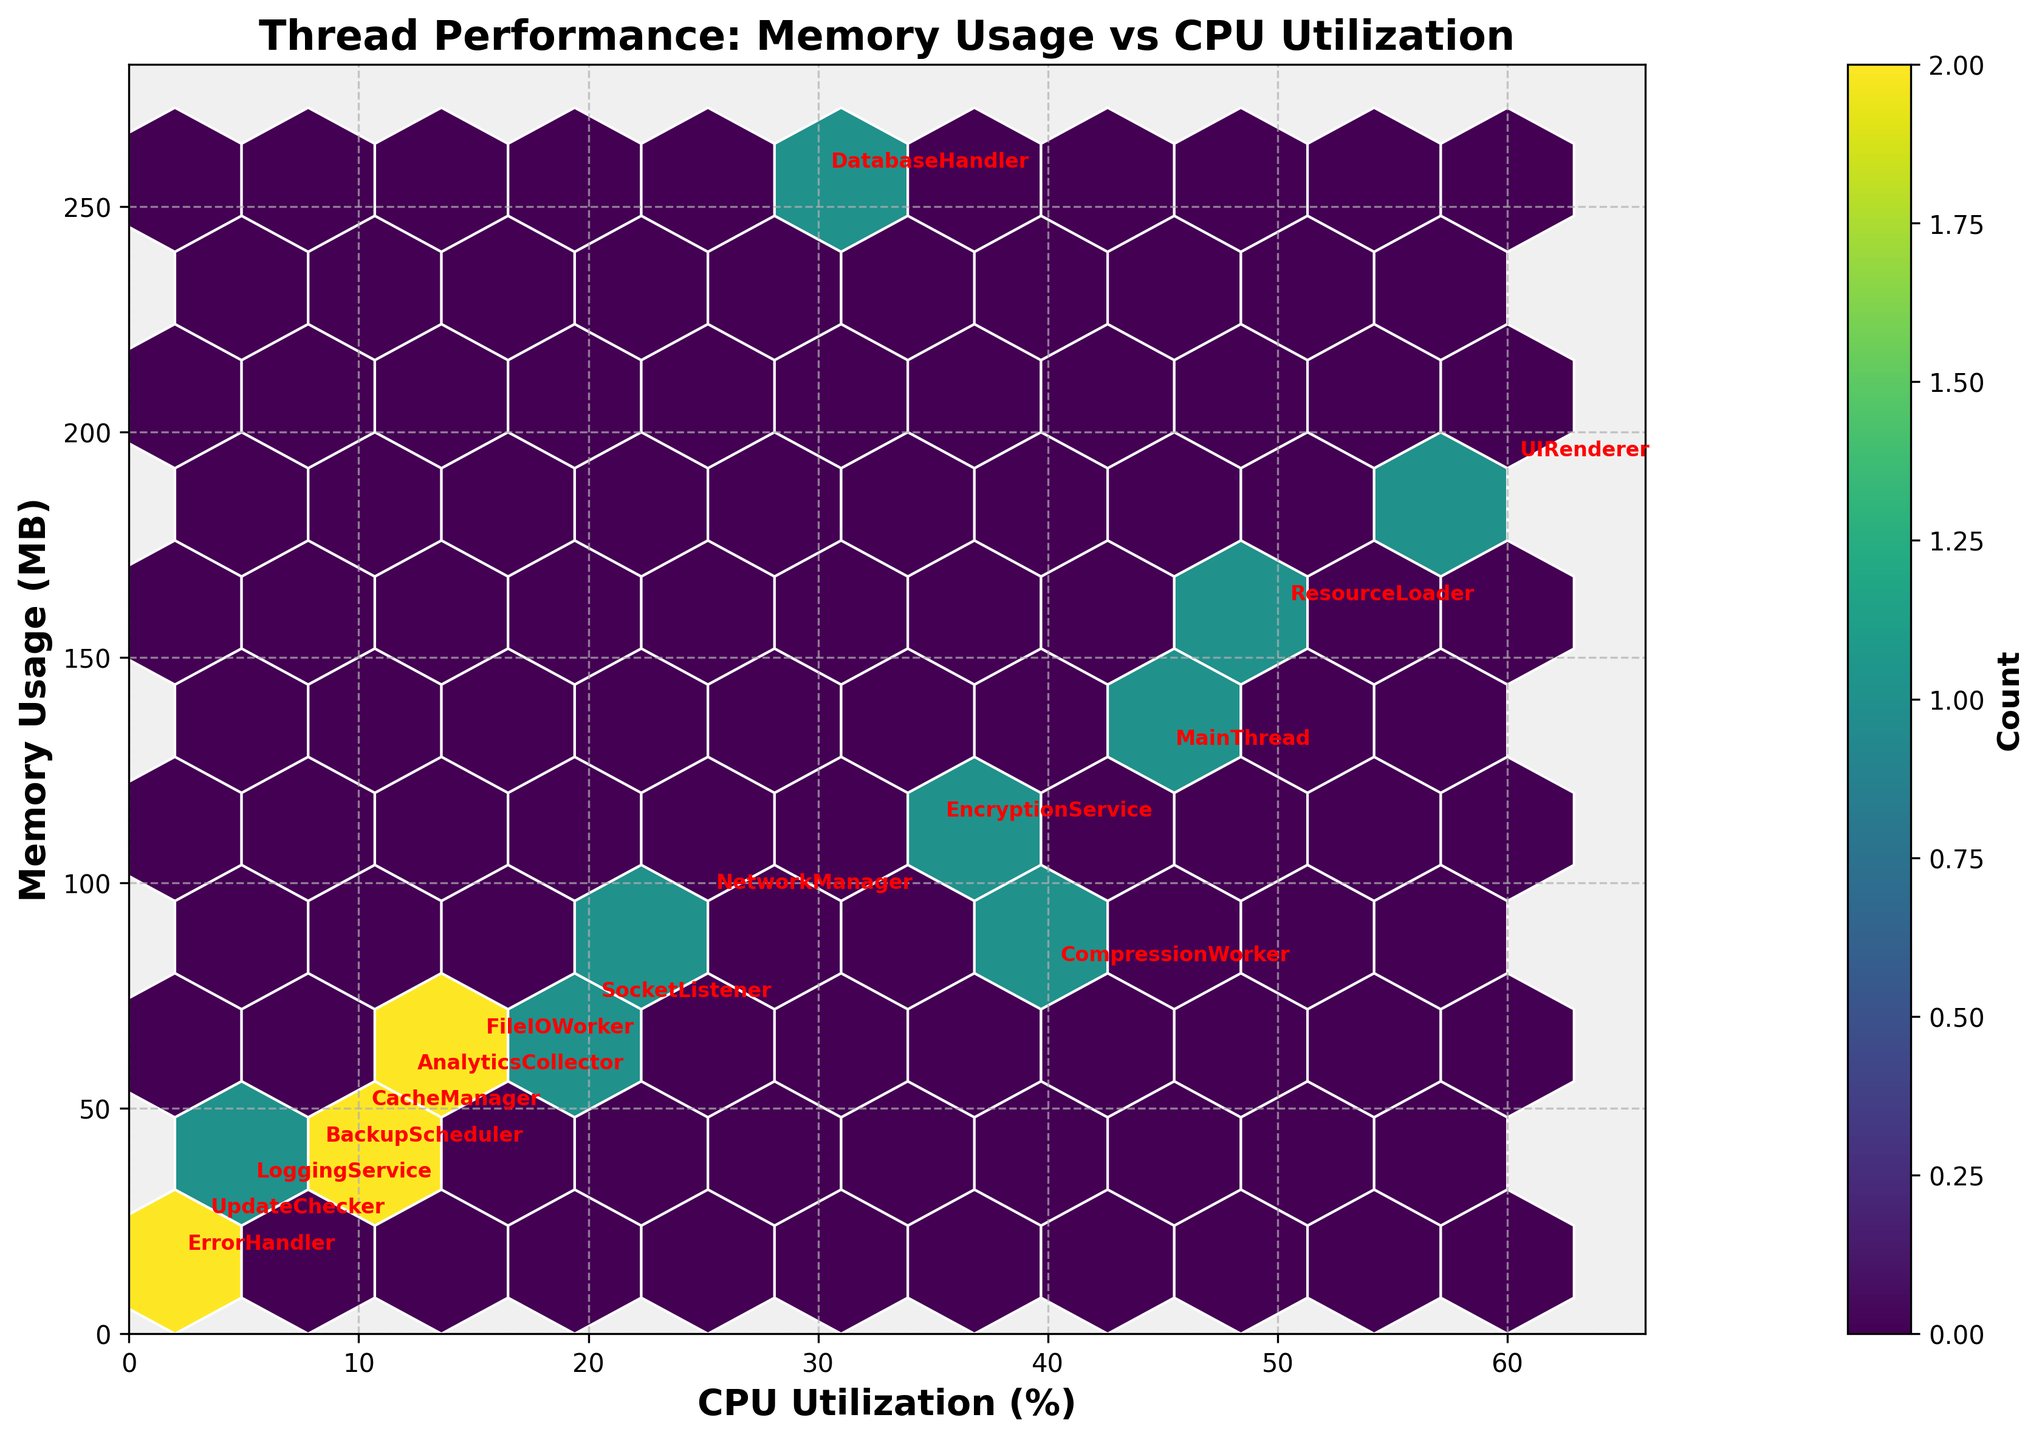What's the title of the figure? The title of the figure is displayed prominently at the top of the plot. It provides a summary of what the plot is about, which is 'Thread Performance: Memory Usage vs CPU Utilization'.
Answer: Thread Performance: Memory Usage vs CPU Utilization What are the labels of the x-axis and y-axis? Axis labels are found along the axes and describe what is being measured. The x-axis is labeled 'CPU Utilization (%)', and the y-axis is labeled 'Memory Usage (MB)'.
Answer: CPU Utilization (%) and Memory Usage (MB) How many hexagons are colored in the figure? The figure uses a hexbin plot, where each hexagon’s color represents the count of data points in that bin. By counting the distinct colored hexagons, we can answer this question. Exact count may require inspection.
Answer: (Count the hexagons in the plot) Which thread has the highest Memory Usage and what is that value? By locating the highest y-value in the plot and checking the annotation for that data point, we can identify the thread. The 'DatabaseHandler' thread is annotated at the y-value of 256 MB.
Answer: DatabaseHandler, 256 MB Which thread has the lowest CPU Utilization and what is that value? Similarly, by locating the lowest x-value and checking the annotation, we identify that the 'ErrorHandler' thread is annotated at the x-value of 2%.
Answer: ErrorHandler, 2% What is the Memory Usage range for threads with CPU Utilization between 20% and 40%? Identify the hexagons located between 20% and 40% on the x-axis and note the range of y-values those hexagons cover. Inspecting the plot, values range from 56 MB to 112 MB.
Answer: 56 MB to 112 MB Which threads have the same CPU Utilization value? Check the annotations for any overlapping x-values. Threads 'CompressionWorker' and 'EncryptionService' both have a CPU Utilization of 35%.
Answer: CompressionWorker and EncryptionService Is there a general correlation between Memory Usage and CPU Utilization? Observe the data points' trend. If the hexagons align along a distinct pattern, describe it. There is a positive trend indicating that as CPU Utilization increases, Memory Usage also tends to increase.
Answer: Yes, generally positive correlation Which thread is annotated closest to the center of the plot? By identifying the central point of the plot's hexagonal grid and finding the closest annotation, it can be noted that 'UIRenderer' seems centrally located with coordinates around (60%, 192 MB).
Answer: UIRenderer What color represents the highest count of data points in the hexagons? Refer to the plot's color bar and find the color that denotes the highest count. Look at the darkest shade in the 'viridis' colormap used.
Answer: The darkest shade in 'viridis' 